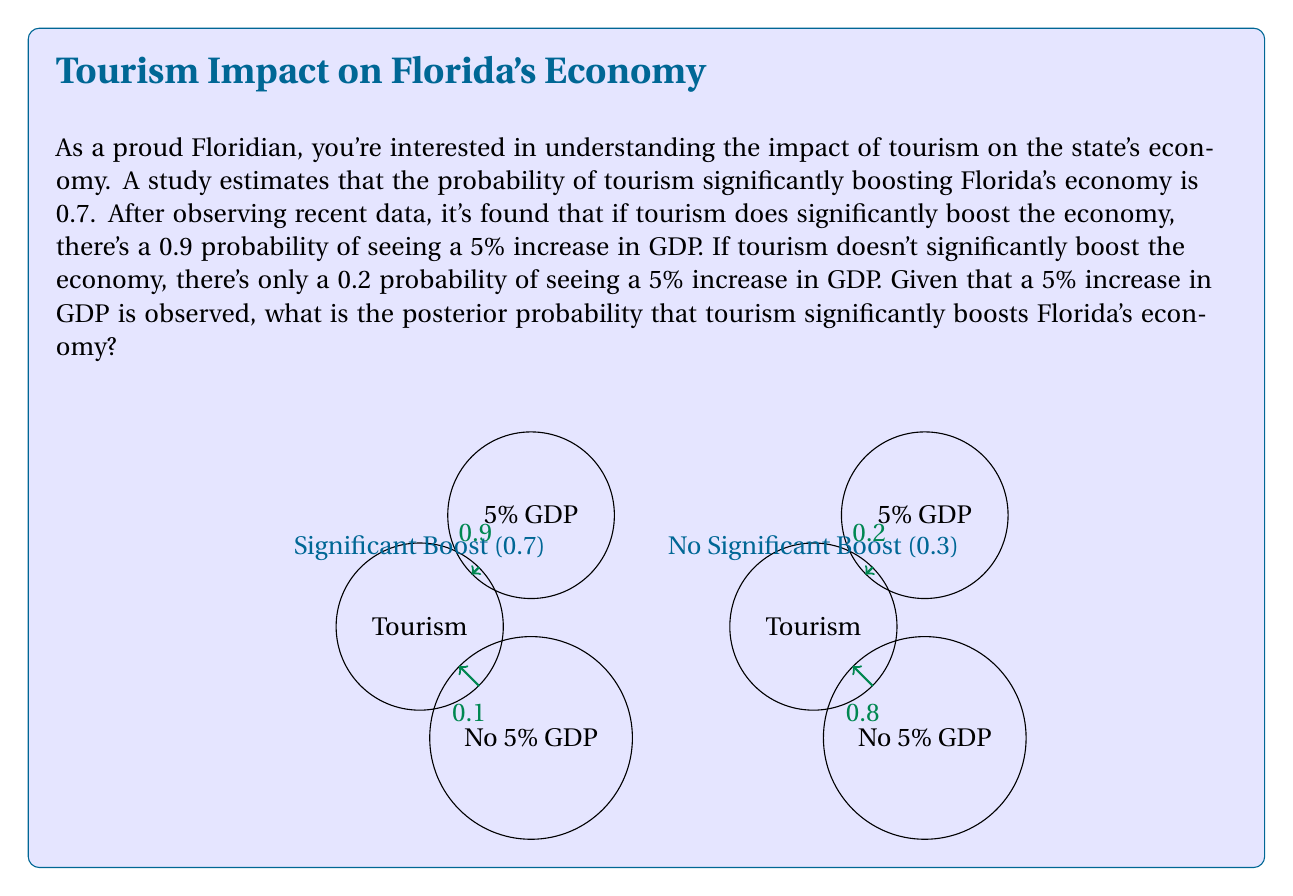Provide a solution to this math problem. Let's approach this problem using Bayes' theorem:

1) Define events:
   A: Tourism significantly boosts the economy
   B: 5% increase in GDP is observed

2) Given probabilities:
   P(A) = 0.7 (prior probability)
   P(B|A) = 0.9 (likelihood if A is true)
   P(B|not A) = 0.2 (likelihood if A is false)

3) Bayes' theorem:
   $$P(A|B) = \frac{P(B|A) \cdot P(A)}{P(B)}$$

4) Calculate P(B) using the law of total probability:
   $$P(B) = P(B|A) \cdot P(A) + P(B|not A) \cdot P(not A)$$
   $$P(B) = 0.9 \cdot 0.7 + 0.2 \cdot 0.3 = 0.63 + 0.06 = 0.69$$

5) Apply Bayes' theorem:
   $$P(A|B) = \frac{0.9 \cdot 0.7}{0.69} = \frac{0.63}{0.69} \approx 0.9130$$

6) Convert to percentage:
   0.9130 * 100% ≈ 91.30%

Therefore, given the observed 5% increase in GDP, the posterior probability that tourism significantly boosts Florida's economy is approximately 91.30%.
Answer: 91.30% 